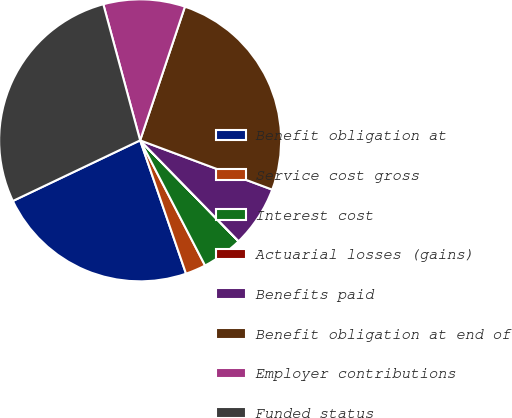<chart> <loc_0><loc_0><loc_500><loc_500><pie_chart><fcel>Benefit obligation at<fcel>Service cost gross<fcel>Interest cost<fcel>Actuarial losses (gains)<fcel>Benefits paid<fcel>Benefit obligation at end of<fcel>Employer contributions<fcel>Funded status<nl><fcel>23.2%<fcel>2.34%<fcel>4.68%<fcel>0.01%<fcel>7.01%<fcel>25.54%<fcel>9.35%<fcel>27.87%<nl></chart> 